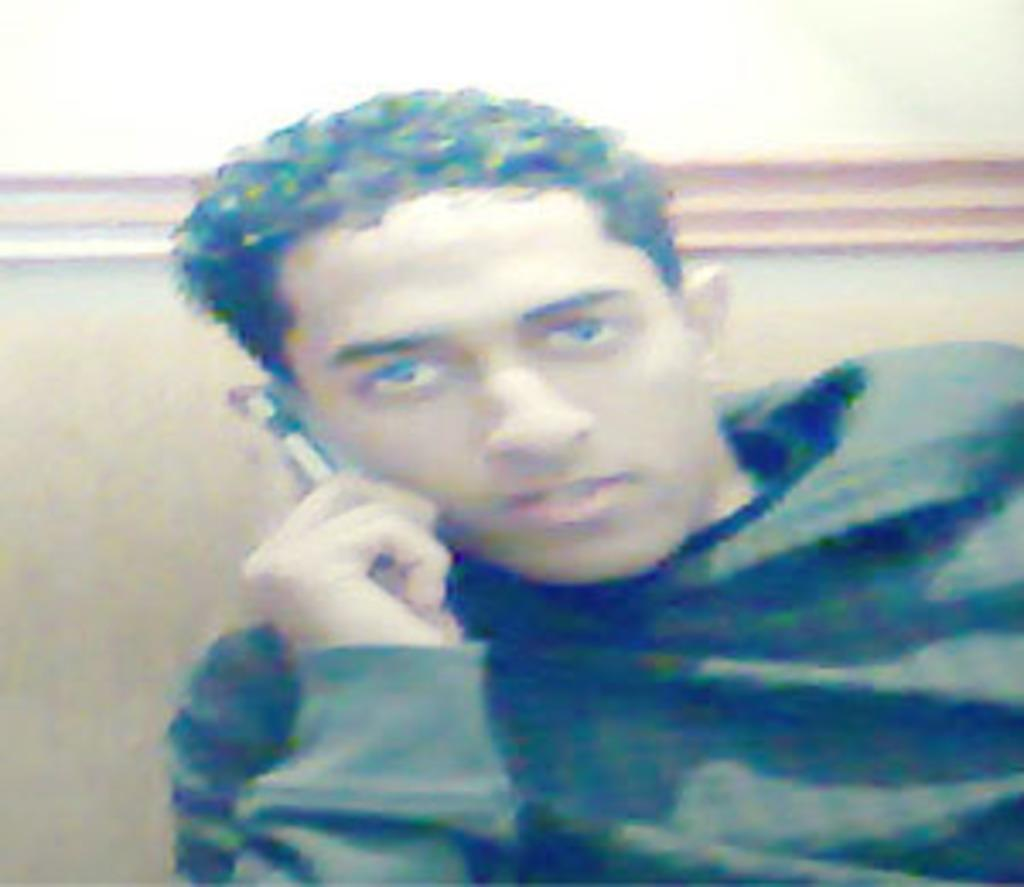Who is present in the image? There is a man in the image. What is the man wearing? The man is wearing a black T-shirt. What is the man doing in the image? The man is talking on the phone. What can be seen in the background of the image? There is a wall in the background of the image. What type of dogs are involved in the fight in the image? There are no dogs or fights present in the image; it features a man talking on the phone. What meal is the man eating in the image? There is no meal present in the image; the man is talking on the phone. 